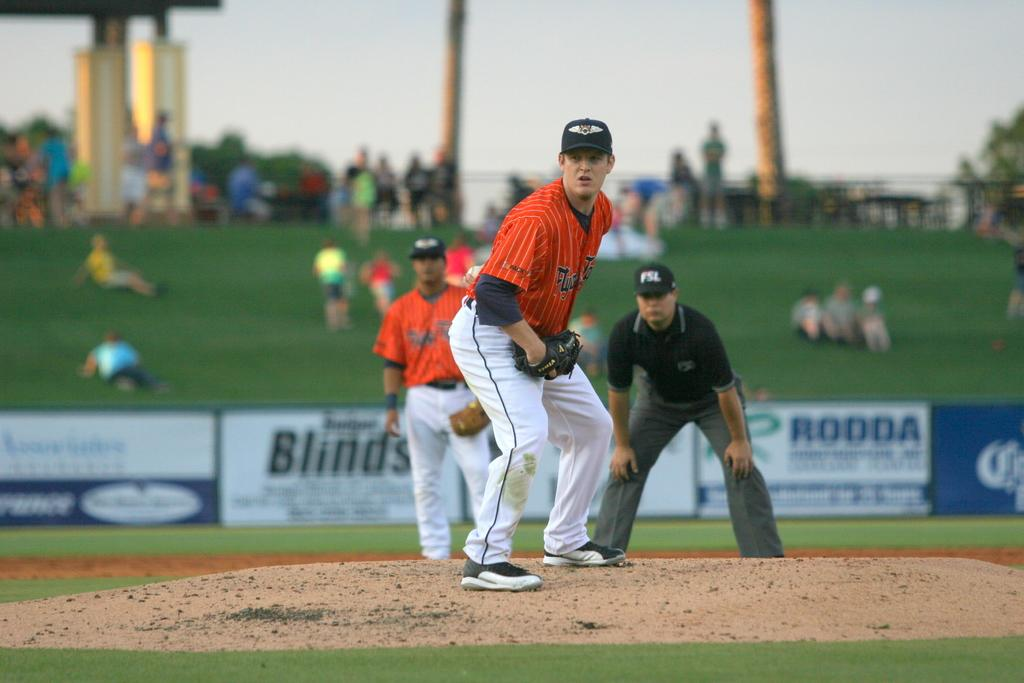<image>
Share a concise interpretation of the image provided. An for Blinds is on the wall of a ballpark behind two players and an ump. 